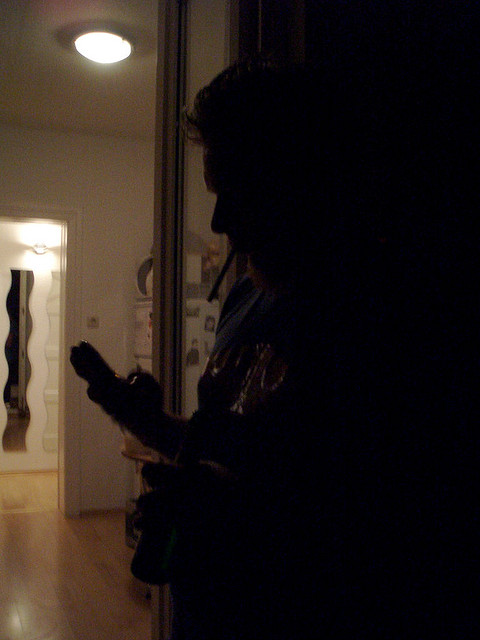<image>What color is the person's shirt? I am not sure about the color of the person's shirt. It could be black, blue, or dark. What color is the person's shirt? I don't know what color is the person's shirt. It can be seen as blue or black. 